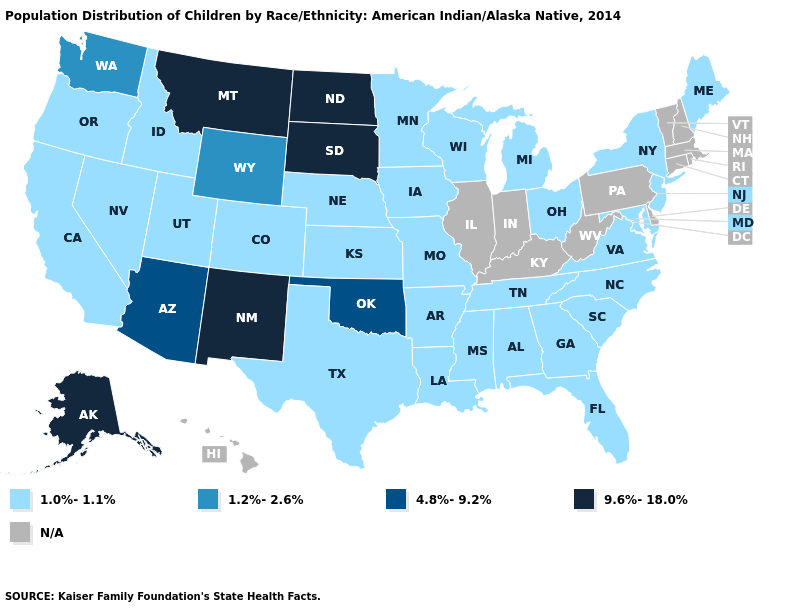What is the value of New Jersey?
Quick response, please. 1.0%-1.1%. What is the value of Mississippi?
Give a very brief answer. 1.0%-1.1%. Name the states that have a value in the range 1.2%-2.6%?
Answer briefly. Washington, Wyoming. Which states have the highest value in the USA?
Be succinct. Alaska, Montana, New Mexico, North Dakota, South Dakota. What is the value of Vermont?
Write a very short answer. N/A. What is the value of Washington?
Concise answer only. 1.2%-2.6%. Does Mississippi have the lowest value in the USA?
Keep it brief. Yes. How many symbols are there in the legend?
Write a very short answer. 5. Does the map have missing data?
Keep it brief. Yes. Among the states that border Indiana , which have the lowest value?
Short answer required. Michigan, Ohio. Among the states that border Florida , which have the lowest value?
Quick response, please. Alabama, Georgia. Which states have the lowest value in the Northeast?
Keep it brief. Maine, New Jersey, New York. 